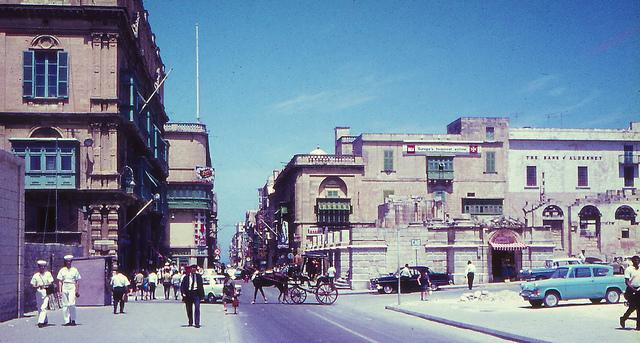Have these buildings seen more history than most of the cars shown?
Be succinct. Yes. What color is the man's shirt?
Give a very brief answer. White. Is there a car?
Give a very brief answer. Yes. Overcast or sunny?
Answer briefly. Sunny. Are the men in white sailors?
Give a very brief answer. Yes. What kinds of transportation are being used?
Keep it brief. Carriage. Is this a modern day photo?
Be succinct. No. How many people are there?
Answer briefly. Many. How many people are on the sidewalk?
Short answer required. Many. What color is the building on the left?
Concise answer only. Brown. What image can be seen on the 4th building?
Give a very brief answer. Sign. 